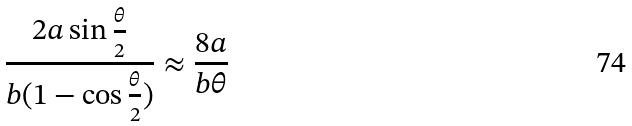Convert formula to latex. <formula><loc_0><loc_0><loc_500><loc_500>\frac { 2 a \sin \frac { \theta } { 2 } } { b ( 1 - \cos \frac { \theta } { 2 } ) } \approx \frac { 8 a } { b \theta }</formula> 